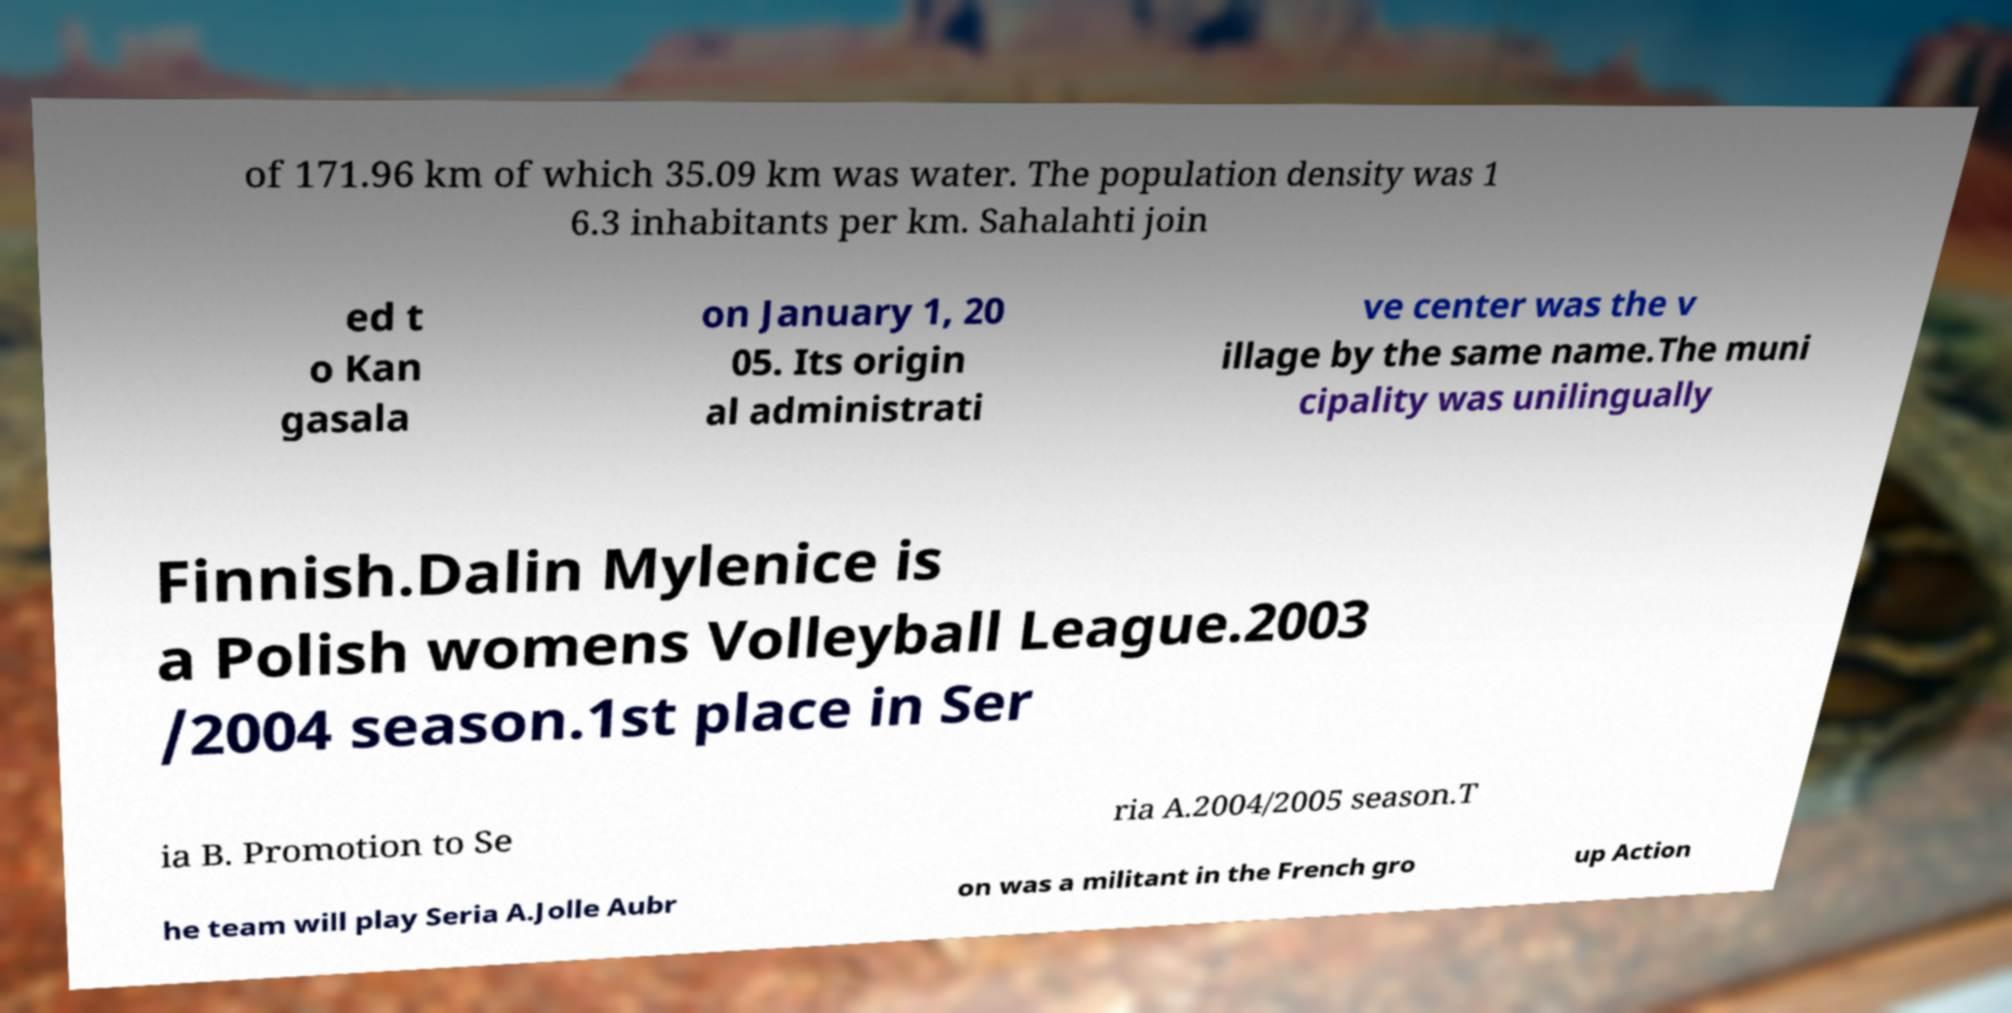Could you assist in decoding the text presented in this image and type it out clearly? of 171.96 km of which 35.09 km was water. The population density was 1 6.3 inhabitants per km. Sahalahti join ed t o Kan gasala on January 1, 20 05. Its origin al administrati ve center was the v illage by the same name.The muni cipality was unilingually Finnish.Dalin Mylenice is a Polish womens Volleyball League.2003 /2004 season.1st place in Ser ia B. Promotion to Se ria A.2004/2005 season.T he team will play Seria A.Jolle Aubr on was a militant in the French gro up Action 